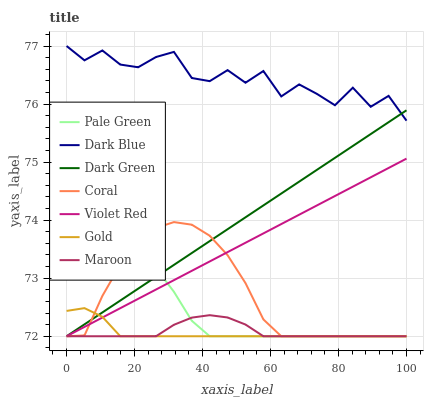Does Gold have the minimum area under the curve?
Answer yes or no. Yes. Does Dark Blue have the maximum area under the curve?
Answer yes or no. Yes. Does Coral have the minimum area under the curve?
Answer yes or no. No. Does Coral have the maximum area under the curve?
Answer yes or no. No. Is Dark Green the smoothest?
Answer yes or no. Yes. Is Dark Blue the roughest?
Answer yes or no. Yes. Is Gold the smoothest?
Answer yes or no. No. Is Gold the roughest?
Answer yes or no. No. Does Dark Blue have the lowest value?
Answer yes or no. No. Does Gold have the highest value?
Answer yes or no. No. Is Coral less than Dark Blue?
Answer yes or no. Yes. Is Dark Blue greater than Coral?
Answer yes or no. Yes. Does Coral intersect Dark Blue?
Answer yes or no. No. 